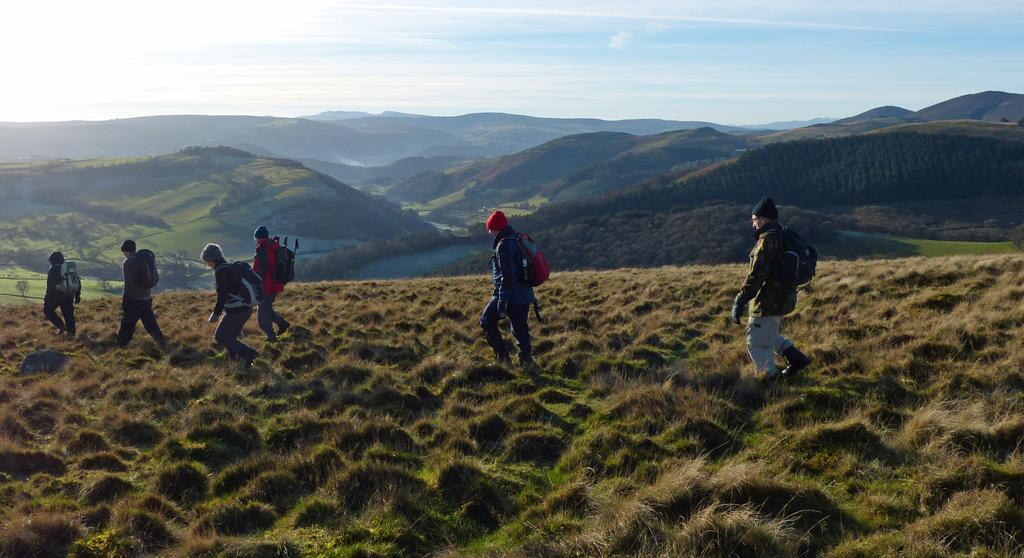How many people are in the image? There is a group of people in the image, but the exact number is not specified. What are the people carrying in the image? The people are carrying bags in the image. What surface are the people walking on? The people are walking on the ground in the image. What can be seen in the background of the image? There are mountains, trees, and the sky visible in the background of the image. What is the condition of the sky in the image? Clouds are present in the sky in the image. What direction are the people walking towards in the image? The direction the people are walking in is not specified in the image. What is the purpose of the people walking in the image? The purpose of the people walking is not mentioned in the image. Can you see any pins in the image? There are no pins visible in the image. 